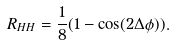<formula> <loc_0><loc_0><loc_500><loc_500>R _ { H H } = \frac { 1 } { 8 } ( 1 - \cos ( 2 \Delta \phi ) ) .</formula> 